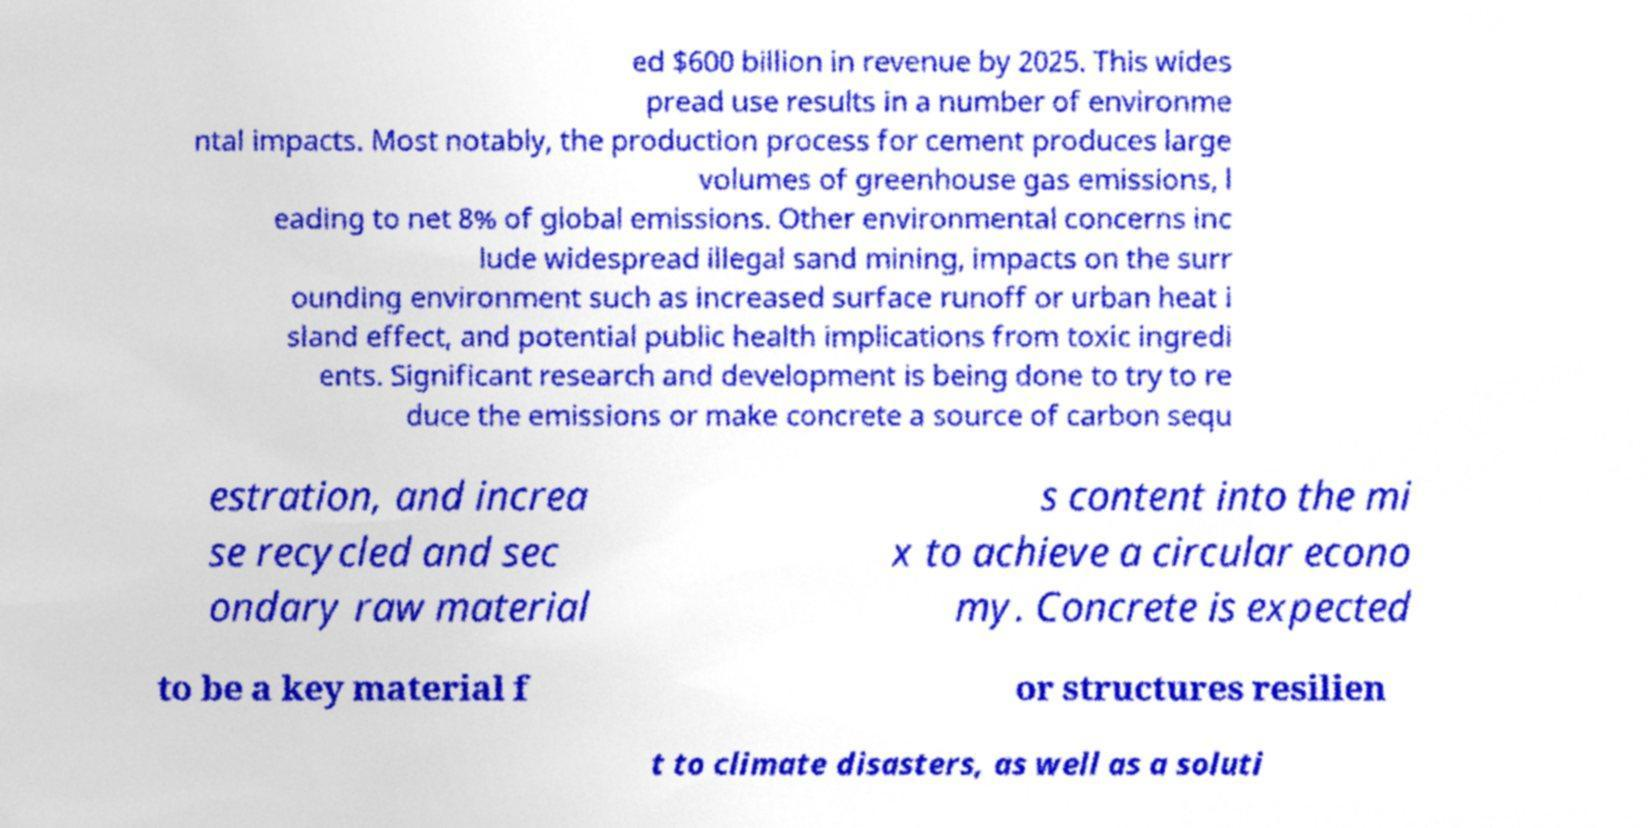Could you assist in decoding the text presented in this image and type it out clearly? ed $600 billion in revenue by 2025. This wides pread use results in a number of environme ntal impacts. Most notably, the production process for cement produces large volumes of greenhouse gas emissions, l eading to net 8% of global emissions. Other environmental concerns inc lude widespread illegal sand mining, impacts on the surr ounding environment such as increased surface runoff or urban heat i sland effect, and potential public health implications from toxic ingredi ents. Significant research and development is being done to try to re duce the emissions or make concrete a source of carbon sequ estration, and increa se recycled and sec ondary raw material s content into the mi x to achieve a circular econo my. Concrete is expected to be a key material f or structures resilien t to climate disasters, as well as a soluti 